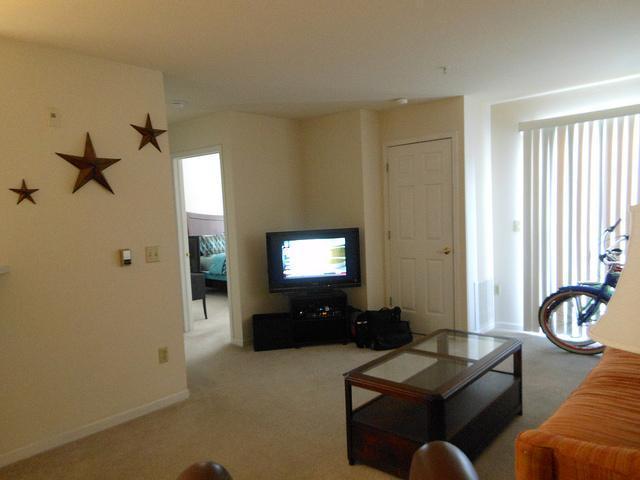How many stars are on the wall?
Give a very brief answer. 3. How many handbags are there?
Give a very brief answer. 1. How many giraffes are there?
Give a very brief answer. 0. 